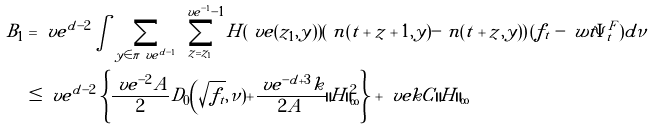Convert formula to latex. <formula><loc_0><loc_0><loc_500><loc_500>B _ { 1 } & = \ v e ^ { d - 2 } \int \sum _ { y \in \pi _ { \ } v e ^ { d - 1 } } \sum _ { z = z _ { 1 } } ^ { \ v e ^ { - 1 } - 1 } H ( \ v e ( z _ { 1 } , y ) ) \left ( \ n ( t + z + 1 , y ) - \ n ( t + z , y ) \right ) ( f _ { t } - \ w t { \Psi } _ { t } ^ { F } ) d \nu \\ & \leq \ v e ^ { d - 2 } \left \{ \frac { \ v e ^ { - 2 } A } { 2 } D _ { 0 } \Big ( \sqrt { f _ { t } } , \nu ) + \frac { \ v e ^ { - d + 3 } k } { 2 A } \| H \| _ { \infty } ^ { 2 } \right \} + \ v e k C \, \| H \| _ { \infty }</formula> 